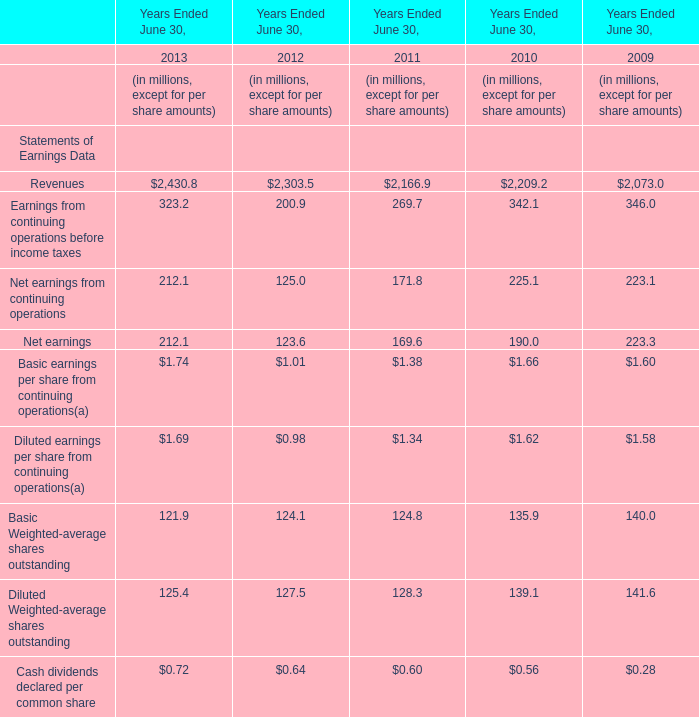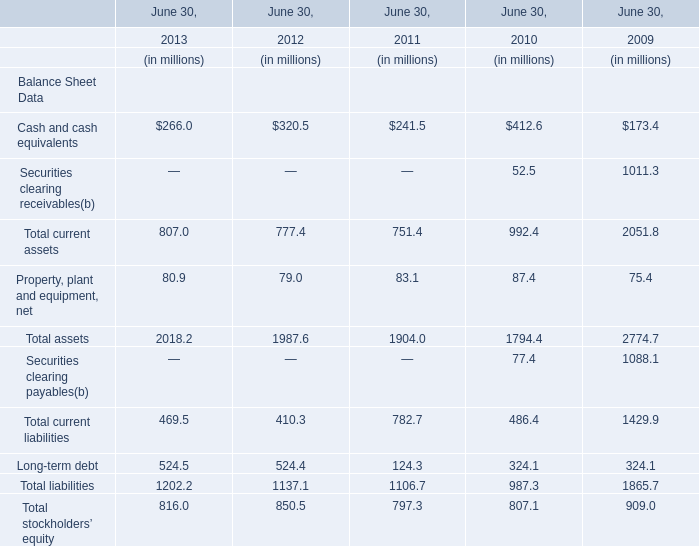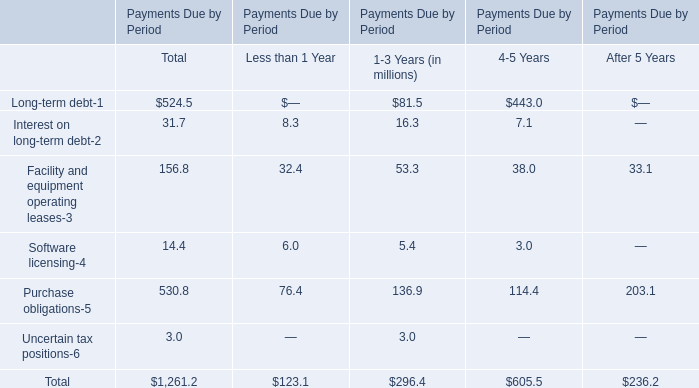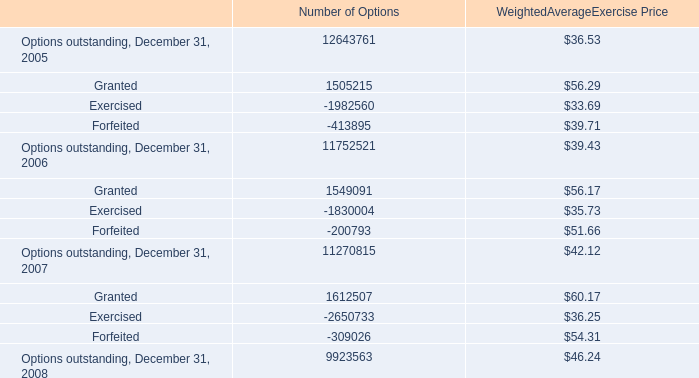In the year with largest amount of Cash and cash equivalents, what's the increasing rate of Total assets? 
Computations: ((1794.4 - 2774.7) / 2774.7)
Answer: -0.3533. 